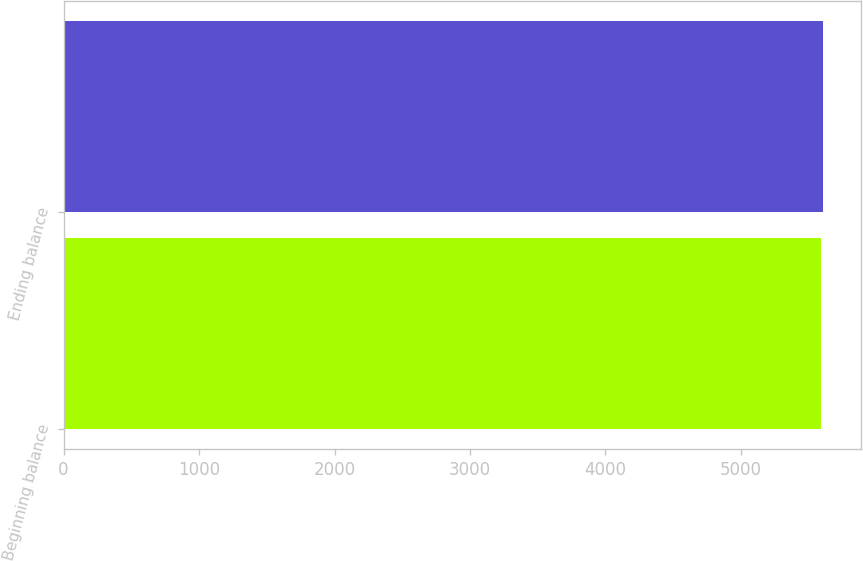Convert chart to OTSL. <chart><loc_0><loc_0><loc_500><loc_500><bar_chart><fcel>Beginning balance<fcel>Ending balance<nl><fcel>5591<fcel>5610<nl></chart> 